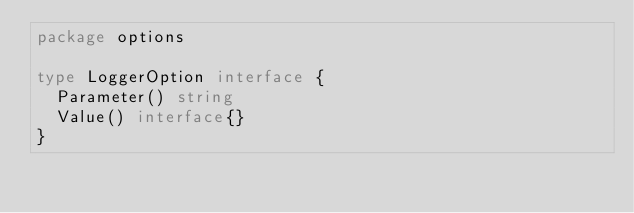<code> <loc_0><loc_0><loc_500><loc_500><_Go_>package options

type LoggerOption interface {
	Parameter() string
	Value() interface{}
}
</code> 